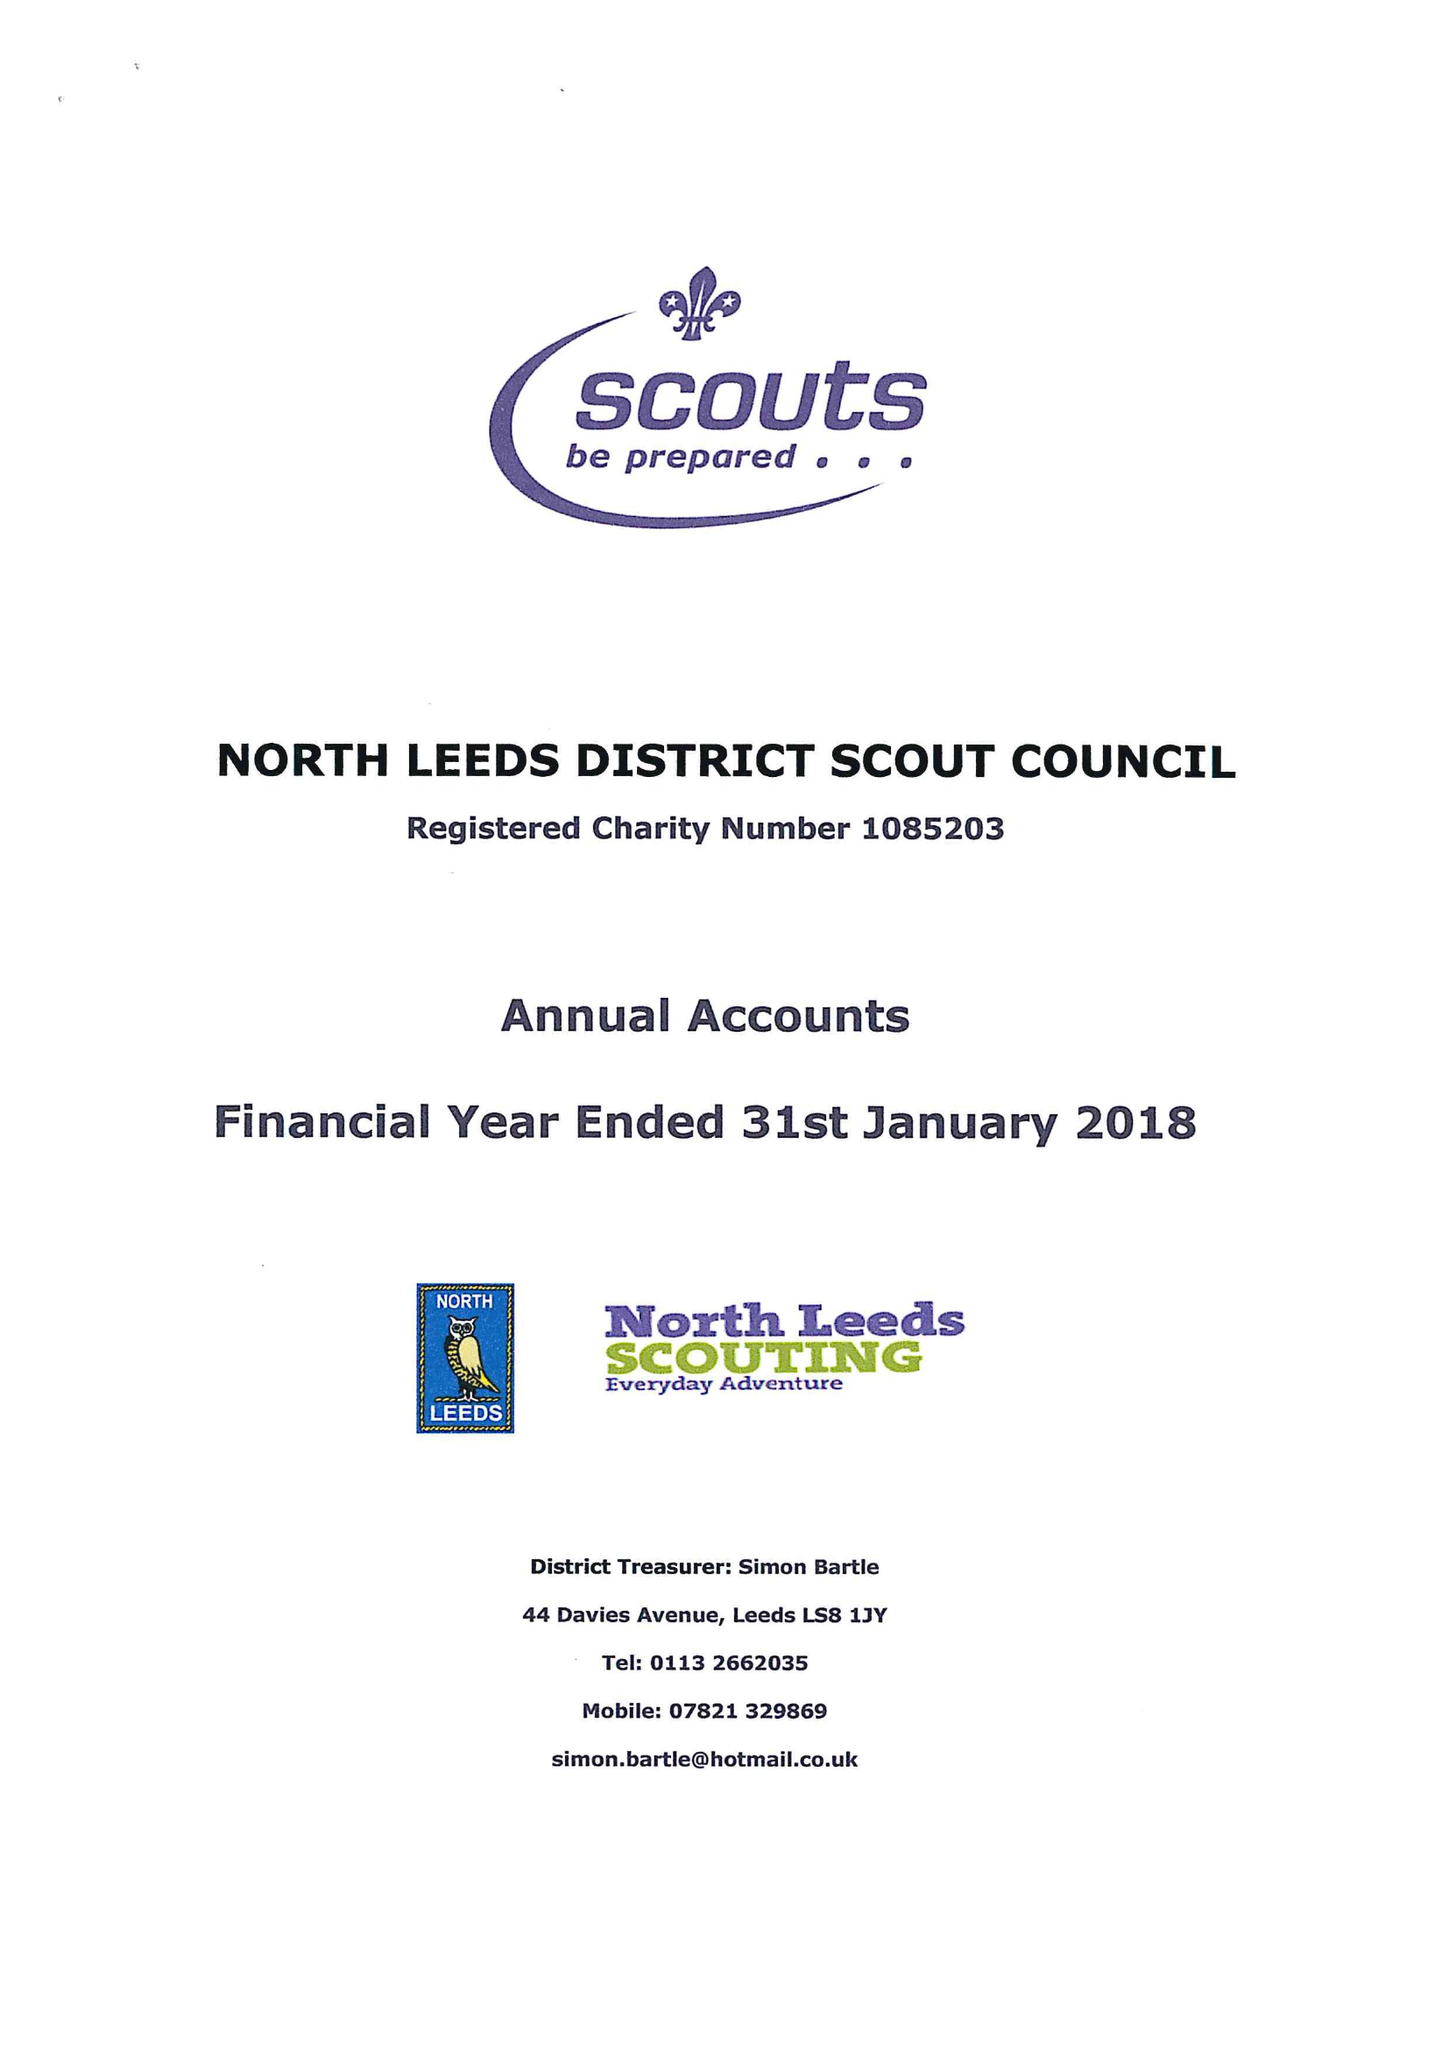What is the value for the income_annually_in_british_pounds?
Answer the question using a single word or phrase. 123249.00 